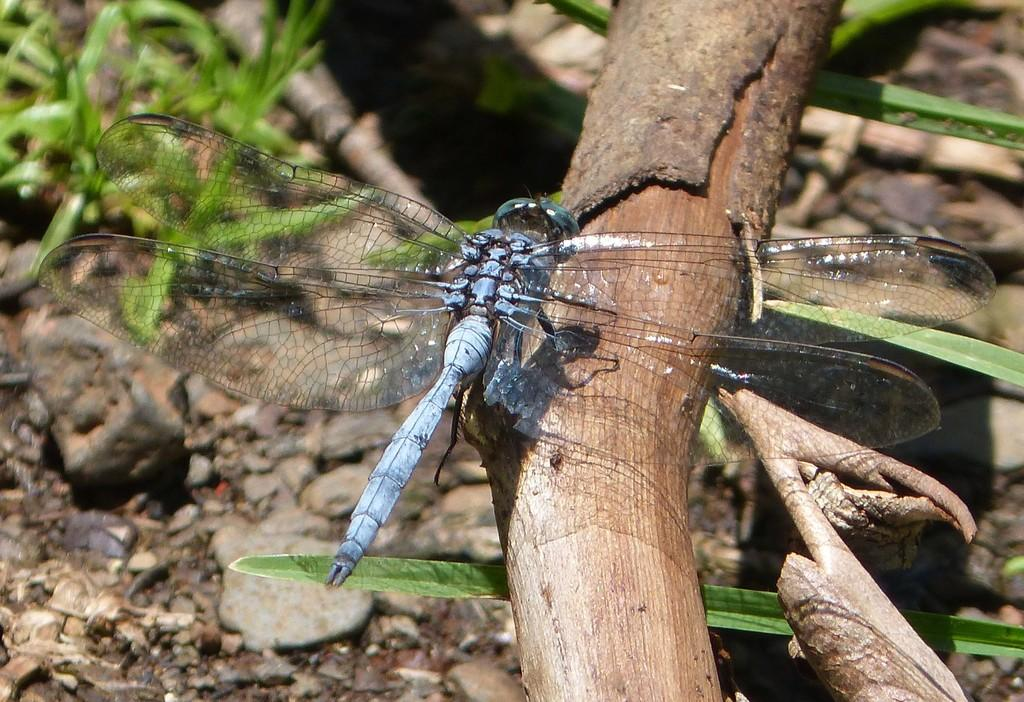What insect is present in the image? There is a dragonfly in the image. What is the dragonfly standing on? The dragonfly is standing on a stick. What can be seen on the ground below the stick? The land below the stick is covered with stones and grass. How many toes does the governor have on the sofa in the image? There is no governor or sofa present in the image, so it is not possible to determine the number of toes. 